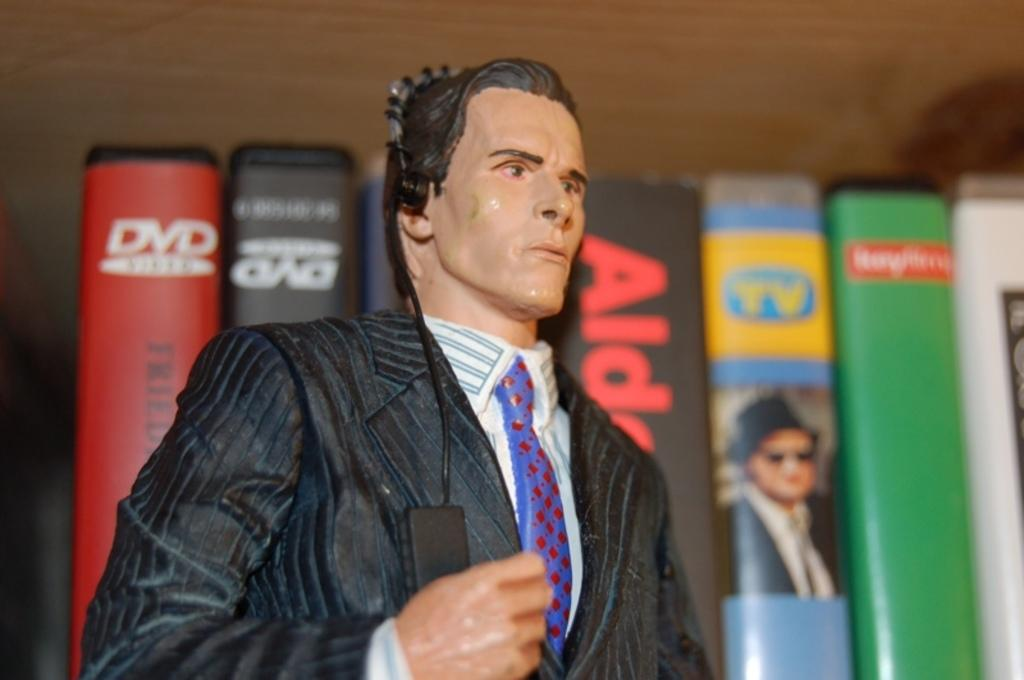What is the main subject of the image? There is a doll in the image. What is the shape of the main subject? The doll is in the shape of a person. What other objects can be seen in the image? There are books in the image. How are the books arranged? The books are arranged. What route does the doll take to get to the books in the image? There is no route or movement depicted in the image; the doll and books are stationary. 